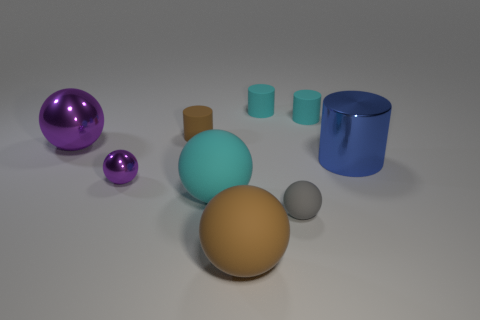There is a rubber object that is both behind the gray rubber thing and in front of the small purple shiny thing; what size is it?
Offer a very short reply. Large. What number of large things are in front of the tiny matte cylinder that is left of the cyan object that is in front of the small brown thing?
Provide a short and direct response. 4. What number of big things are either metallic blocks or blue cylinders?
Ensure brevity in your answer.  1. Is the cyan thing that is in front of the small brown matte cylinder made of the same material as the gray thing?
Provide a short and direct response. Yes. What material is the purple thing right of the purple metallic ball left of the metal ball in front of the blue metal object?
Make the answer very short. Metal. How many metal things are either tiny balls or purple things?
Offer a terse response. 2. Are any gray shiny blocks visible?
Your response must be concise. No. There is a shiny object right of the big matte thing on the left side of the large brown matte ball; what is its color?
Offer a very short reply. Blue. How many other things are the same color as the big cylinder?
Provide a succinct answer. 0. What number of things are either large blue metallic objects or tiny objects right of the tiny purple metal ball?
Offer a very short reply. 5. 